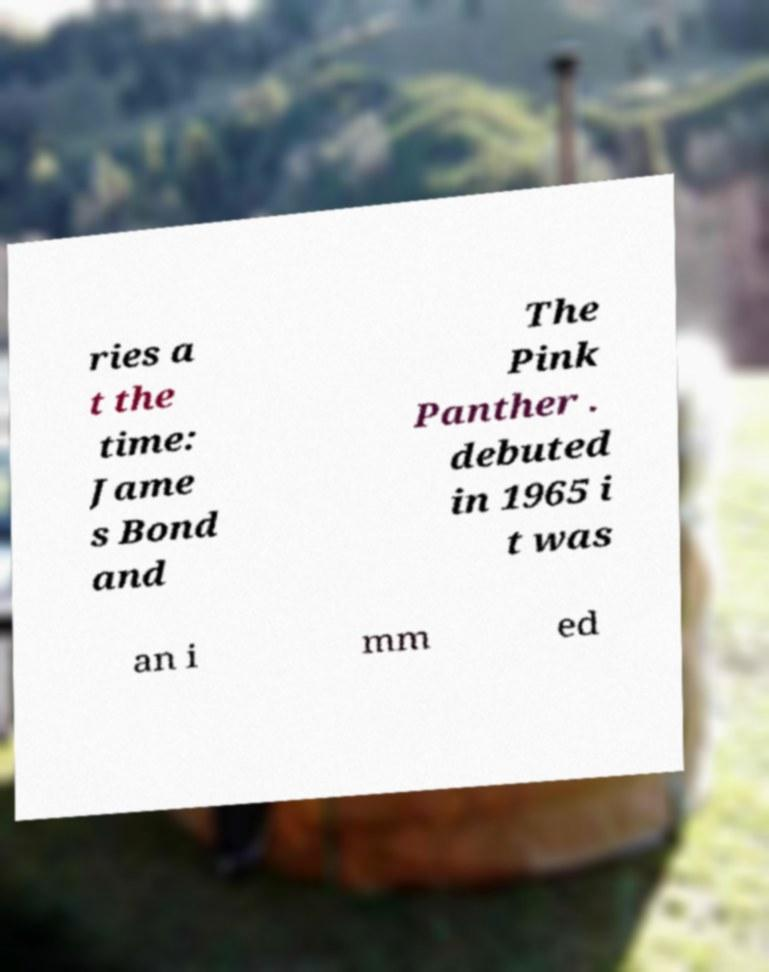I need the written content from this picture converted into text. Can you do that? ries a t the time: Jame s Bond and The Pink Panther . debuted in 1965 i t was an i mm ed 